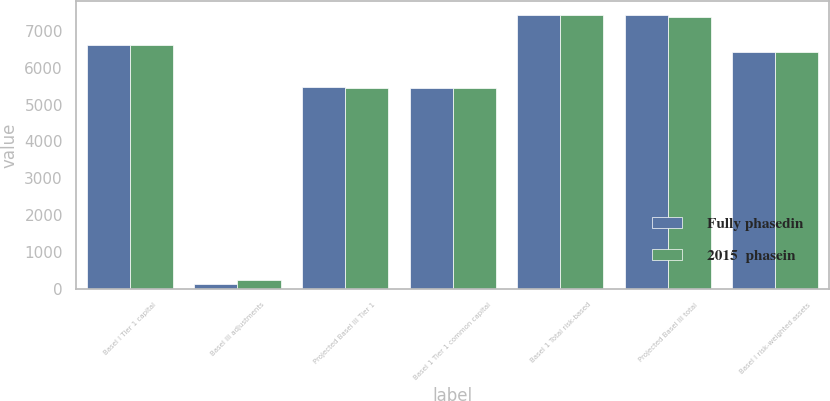<chart> <loc_0><loc_0><loc_500><loc_500><stacked_bar_chart><ecel><fcel>Basel I Tier 1 capital<fcel>Basel III adjustments<fcel>Projected Basel III Tier 1<fcel>Basel 1 Tier 1 common capital<fcel>Basel 1 Total risk-based<fcel>Projected Basel III total<fcel>Basel I risk-weighted assets<nl><fcel>Fully phasedin<fcel>6620<fcel>131<fcel>5469<fcel>5453<fcel>7443<fcel>7439<fcel>6441.5<nl><fcel>2015  phasein<fcel>6620<fcel>226<fcel>5454<fcel>5453<fcel>7443<fcel>7385<fcel>6441.5<nl></chart> 